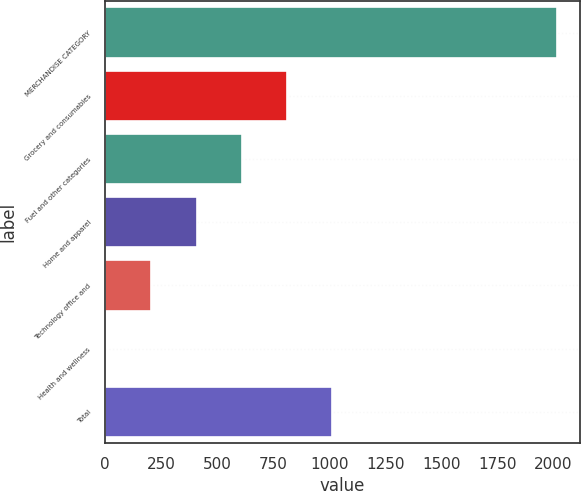Convert chart to OTSL. <chart><loc_0><loc_0><loc_500><loc_500><bar_chart><fcel>MERCHANDISE CATEGORY<fcel>Grocery and consumables<fcel>Fuel and other categories<fcel>Home and apparel<fcel>Technology office and<fcel>Health and wellness<fcel>Total<nl><fcel>2016<fcel>809.4<fcel>608.3<fcel>407.2<fcel>206.1<fcel>5<fcel>1010.5<nl></chart> 